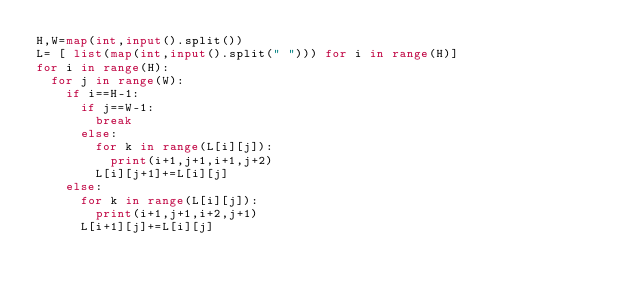Convert code to text. <code><loc_0><loc_0><loc_500><loc_500><_Python_>H,W=map(int,input().split())
L= [ list(map(int,input().split(" "))) for i in range(H)]
for i in range(H):
  for j in range(W):
    if i==H-1:
      if j==W-1:
        break
      else:
        for k in range(L[i][j]):
          print(i+1,j+1,i+1,j+2)
        L[i][j+1]+=L[i][j]
    else:
      for k in range(L[i][j]):
        print(i+1,j+1,i+2,j+1)
      L[i+1][j]+=L[i][j]</code> 